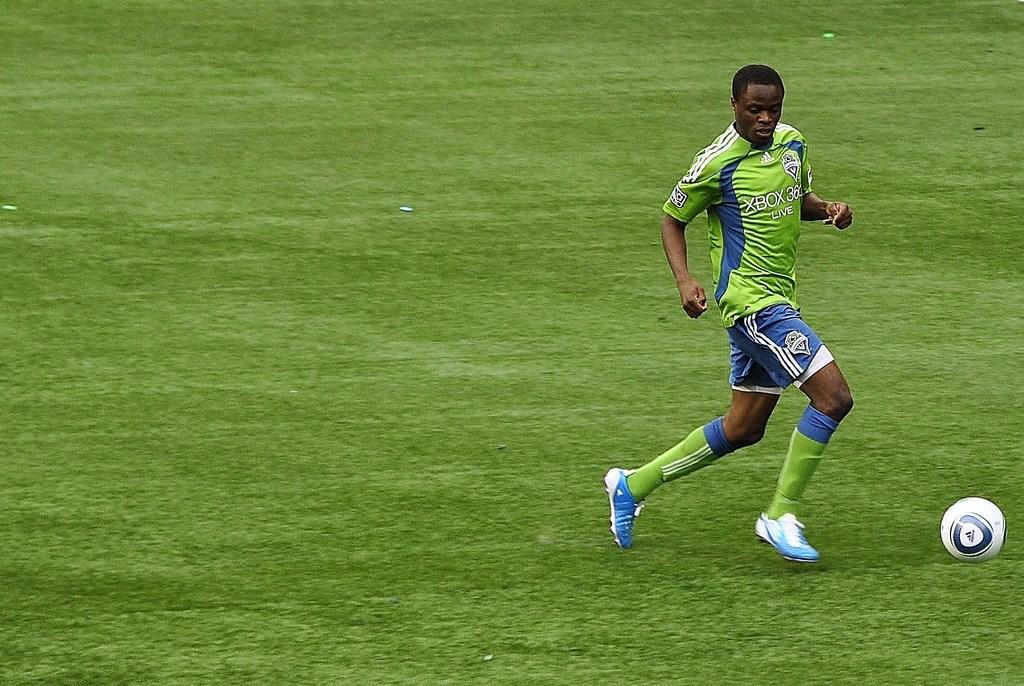How would you summarize this image in a sentence or two? In this picture there is a man who is wearing t-shirt, short and shoes. He is running towards the football. In the left there is a football ground. At the bottom I can see the grass. 